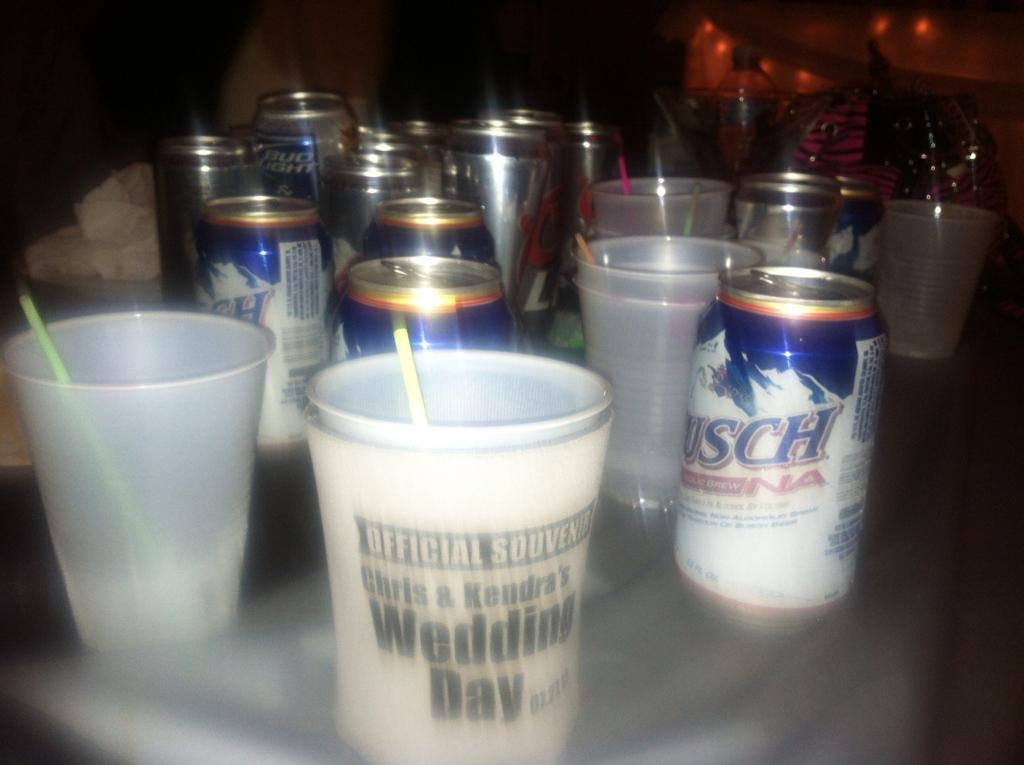What objects are present in the image? There are glasses and coke bottles in the image. What colors are the glasses and coke bottles? The glasses and coke bottles are in white and blue colors. What is the color of the background in the image? The background of the image is black. How is the background of the image depicted? The background of the image is blurred. What note is the achiever playing on the piano in the image? There is no piano or achiever present in the image; it only features glasses and coke bottles. What type of party is being depicted in the image? There is no party depicted in the image; it only shows glasses and coke bottles. 